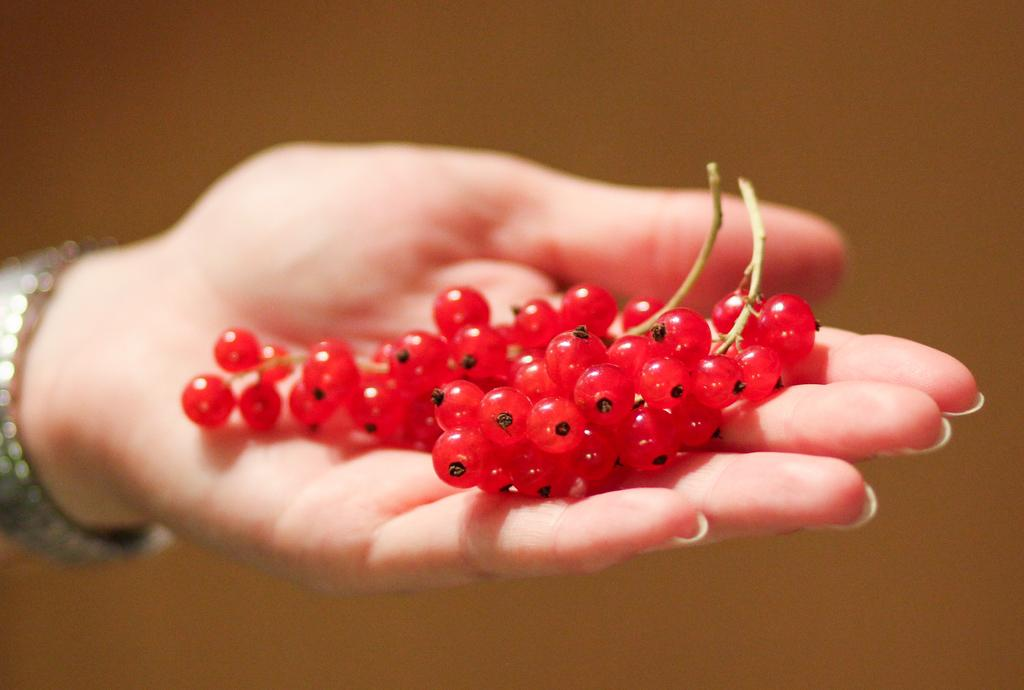What part of the person's body is visible in the image? There is a person's hand in the image. What is the person holding in their hand? The person is holding berries. What color are the berries? The berries are red in color. What type of texture can be seen on the person's hand in the image? There is no information about the texture of the person's hand in the image. 